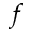<formula> <loc_0><loc_0><loc_500><loc_500>f</formula> 